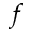<formula> <loc_0><loc_0><loc_500><loc_500>f</formula> 